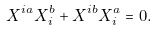<formula> <loc_0><loc_0><loc_500><loc_500>X ^ { i a } X _ { i } ^ { b } + X ^ { i b } X _ { i } ^ { a } = 0 .</formula> 